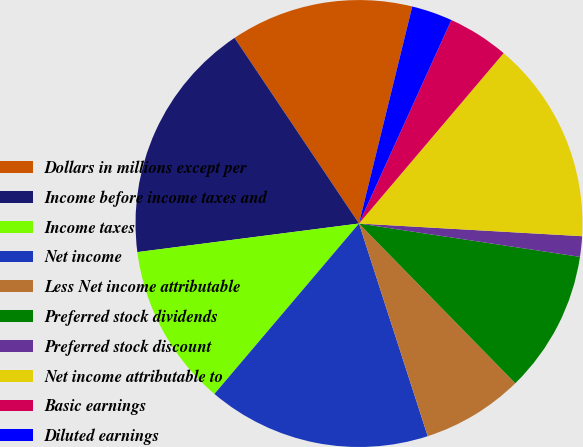<chart> <loc_0><loc_0><loc_500><loc_500><pie_chart><fcel>Dollars in millions except per<fcel>Income before income taxes and<fcel>Income taxes<fcel>Net income<fcel>Less Net income attributable<fcel>Preferred stock dividends<fcel>Preferred stock discount<fcel>Net income attributable to<fcel>Basic earnings<fcel>Diluted earnings<nl><fcel>13.23%<fcel>17.64%<fcel>11.76%<fcel>16.17%<fcel>7.35%<fcel>10.29%<fcel>1.48%<fcel>14.7%<fcel>4.42%<fcel>2.95%<nl></chart> 